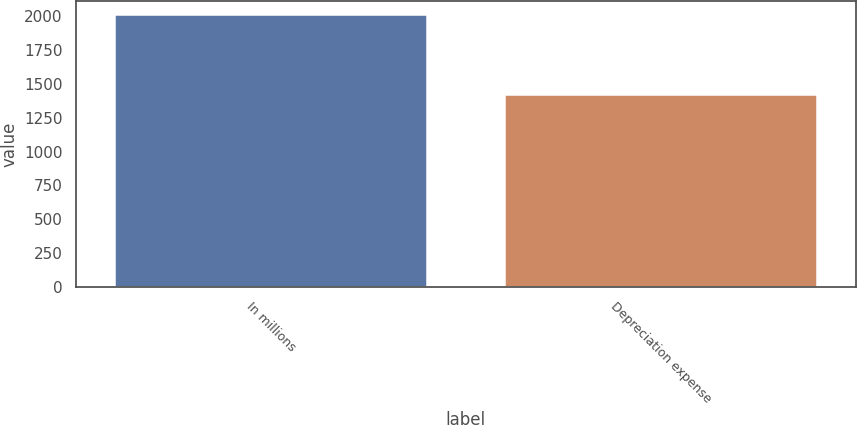<chart> <loc_0><loc_0><loc_500><loc_500><bar_chart><fcel>In millions<fcel>Depreciation expense<nl><fcel>2013<fcel>1415<nl></chart> 